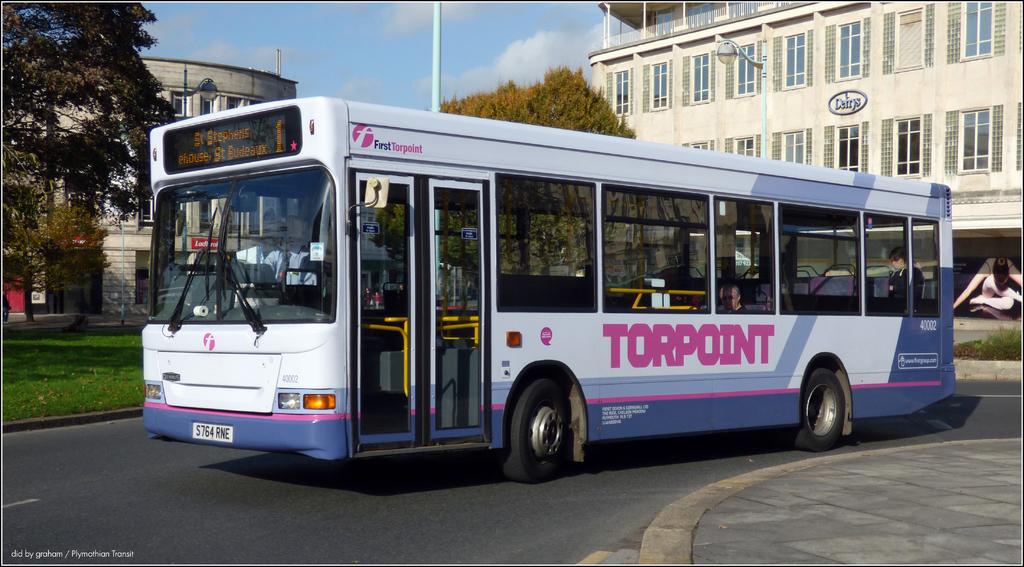What is the name of the bus company?
Offer a very short reply. Torpoint. What is the buses' license plate number?
Give a very brief answer. S764rne. 